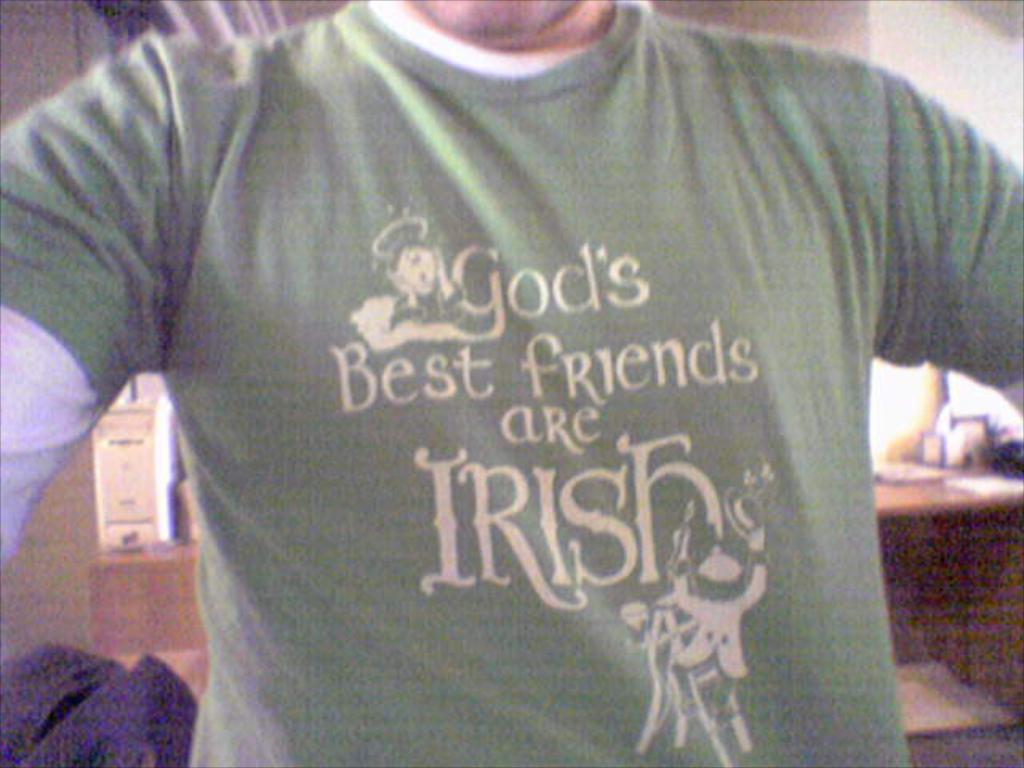What is present in the image? There is a man in the image. Can you describe the man's clothing? The man is wearing a green and white color T-shirt. What type of insect can be seen crawling on the man's T-shirt in the image? There is no insect present on the man's T-shirt in the image. 